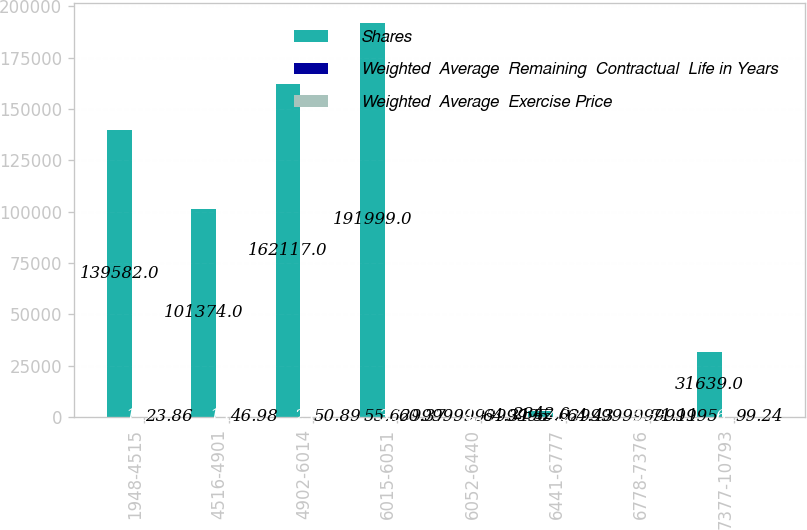Convert chart to OTSL. <chart><loc_0><loc_0><loc_500><loc_500><stacked_bar_chart><ecel><fcel>1948-4515<fcel>4516-4901<fcel>4902-6014<fcel>6015-6051<fcel>6052-6440<fcel>6441-6777<fcel>6778-7376<fcel>7377-10793<nl><fcel>Shares<fcel>139582<fcel>101374<fcel>162117<fcel>191999<fcel>55.63<fcel>2842<fcel>55.63<fcel>31639<nl><fcel>Weighted  Average  Remaining  Contractual  Life in Years<fcel>1.55<fcel>1.64<fcel>2.66<fcel>3.32<fcel>4.33<fcel>4.25<fcel>5.33<fcel>6.31<nl><fcel>Weighted  Average  Exercise Price<fcel>23.86<fcel>46.98<fcel>50.89<fcel>60.37<fcel>64.31<fcel>64.43<fcel>71.11<fcel>99.24<nl></chart> 